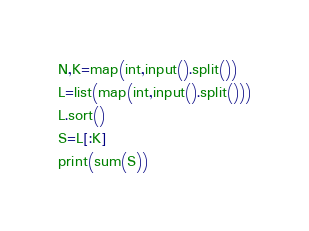Convert code to text. <code><loc_0><loc_0><loc_500><loc_500><_Python_>N,K=map(int,input().split())
L=list(map(int,input().split()))
L.sort()
S=L[:K]
print(sum(S))</code> 